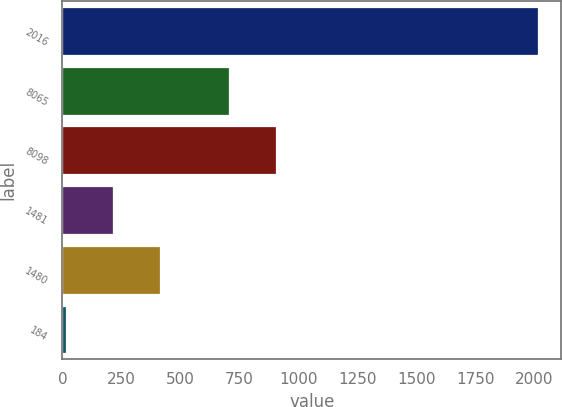Convert chart to OTSL. <chart><loc_0><loc_0><loc_500><loc_500><bar_chart><fcel>2016<fcel>8065<fcel>8098<fcel>1481<fcel>1480<fcel>184<nl><fcel>2014<fcel>705.2<fcel>905.04<fcel>215.44<fcel>415.28<fcel>15.6<nl></chart> 